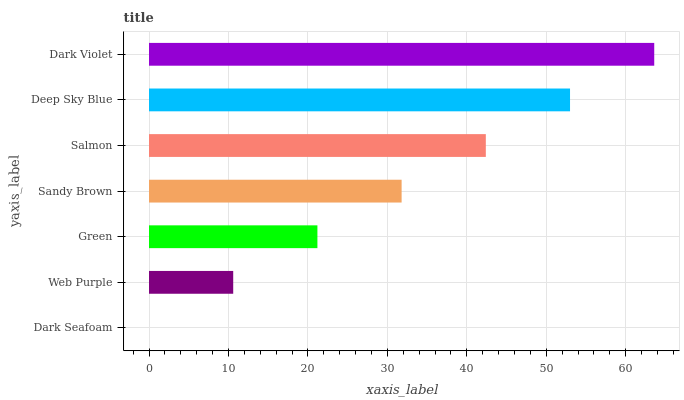Is Dark Seafoam the minimum?
Answer yes or no. Yes. Is Dark Violet the maximum?
Answer yes or no. Yes. Is Web Purple the minimum?
Answer yes or no. No. Is Web Purple the maximum?
Answer yes or no. No. Is Web Purple greater than Dark Seafoam?
Answer yes or no. Yes. Is Dark Seafoam less than Web Purple?
Answer yes or no. Yes. Is Dark Seafoam greater than Web Purple?
Answer yes or no. No. Is Web Purple less than Dark Seafoam?
Answer yes or no. No. Is Sandy Brown the high median?
Answer yes or no. Yes. Is Sandy Brown the low median?
Answer yes or no. Yes. Is Dark Seafoam the high median?
Answer yes or no. No. Is Web Purple the low median?
Answer yes or no. No. 